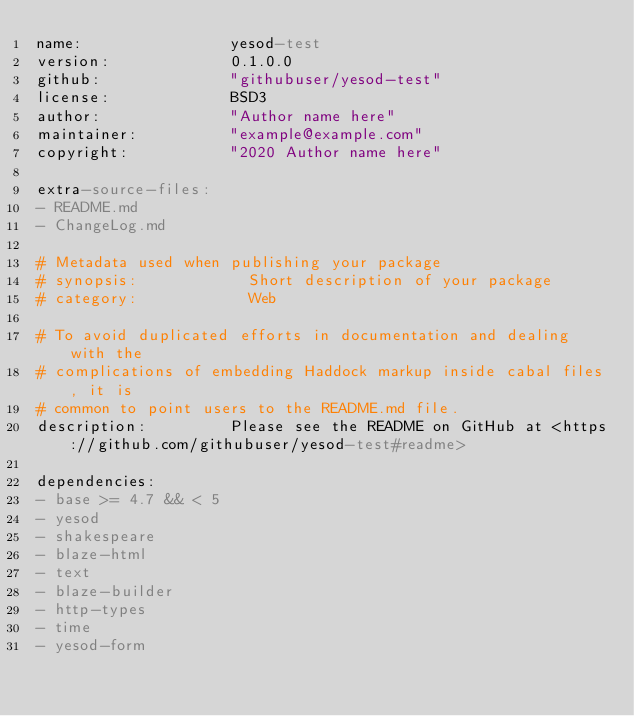<code> <loc_0><loc_0><loc_500><loc_500><_YAML_>name:                yesod-test
version:             0.1.0.0
github:              "githubuser/yesod-test"
license:             BSD3
author:              "Author name here"
maintainer:          "example@example.com"
copyright:           "2020 Author name here"

extra-source-files:
- README.md
- ChangeLog.md

# Metadata used when publishing your package
# synopsis:            Short description of your package
# category:            Web

# To avoid duplicated efforts in documentation and dealing with the
# complications of embedding Haddock markup inside cabal files, it is
# common to point users to the README.md file.
description:         Please see the README on GitHub at <https://github.com/githubuser/yesod-test#readme>

dependencies:
- base >= 4.7 && < 5
- yesod
- shakespeare
- blaze-html
- text
- blaze-builder
- http-types
- time
- yesod-form</code> 